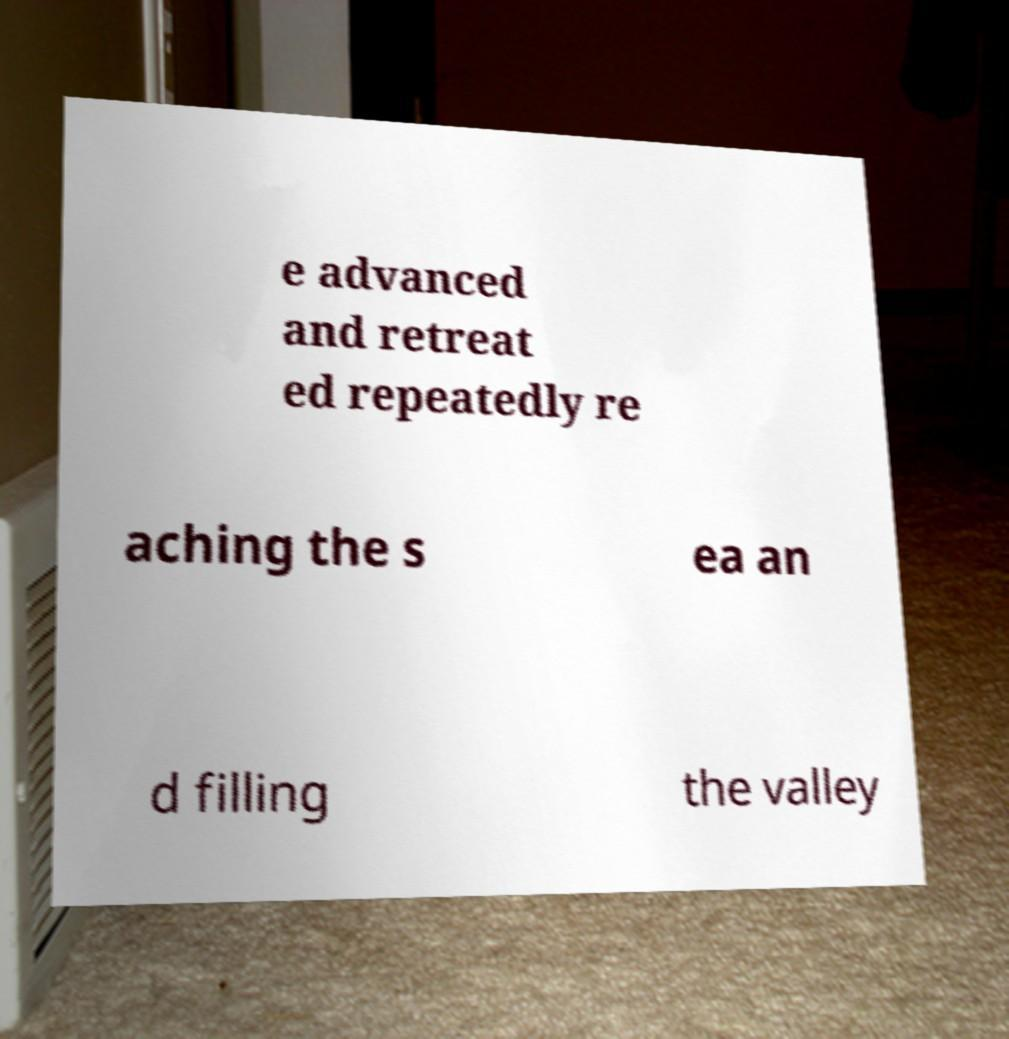Please identify and transcribe the text found in this image. e advanced and retreat ed repeatedly re aching the s ea an d filling the valley 